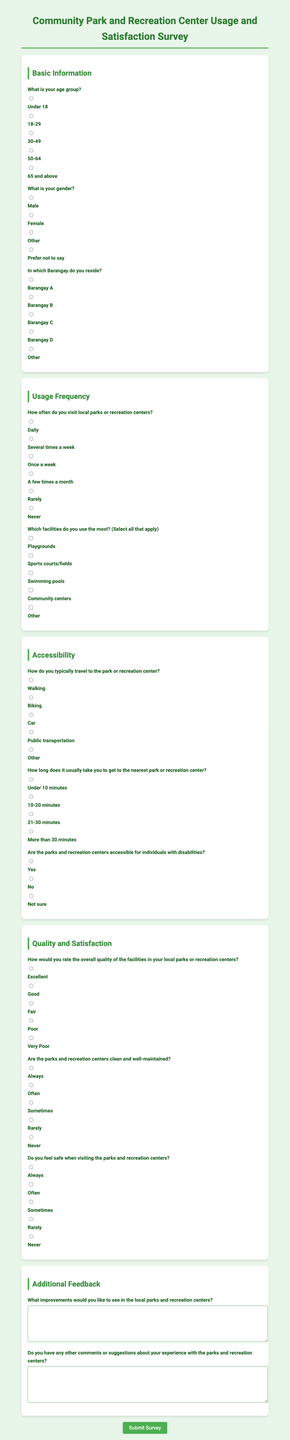What is the title of the survey? The title is provided in the header of the document as part of the main heading.
Answer: Community Park and Recreation Center Usage and Satisfaction Survey How many sections are in the survey? The document includes multiple sections, each covering a different topic.
Answer: Four What is the first question about? The first question asks for demographic information specific to age, which is required to categorize responses.
Answer: Age group What type of transportation options are provided for traveling to parks? The document lists multiple modes of transport that survey respondents can select to indicate how they travel.
Answer: Walking, Biking, Car, Public transportation, Other How would respondents rate the overall quality of the facilities? This question allows respondents to express their subjective evaluation of the facilities available at parks.
Answer: Excellent, Good, Fair, Poor, Very Poor What are two types of facilities listed for usage? The survey asks about various amenities available at local parks with multiple options.
Answer: Playgrounds, Sports courts/fields Are the parks accessible for individuals with disabilities? The survey includes a specific question about accessibility, indicating consideration for all users.
Answer: Yes, No, Not sure What is being requested in the additional feedback section? The survey specifically asks for suggestions or comments regarding the parks and recreation centers from respondents.
Answer: Improvements and comments How often is the frequency of park visits asked? The frequency section queries how often individuals utilize local parks or recreation centers.
Answer: Daily, Several times a week, Once a week, A few times a month, Rarely, Never 